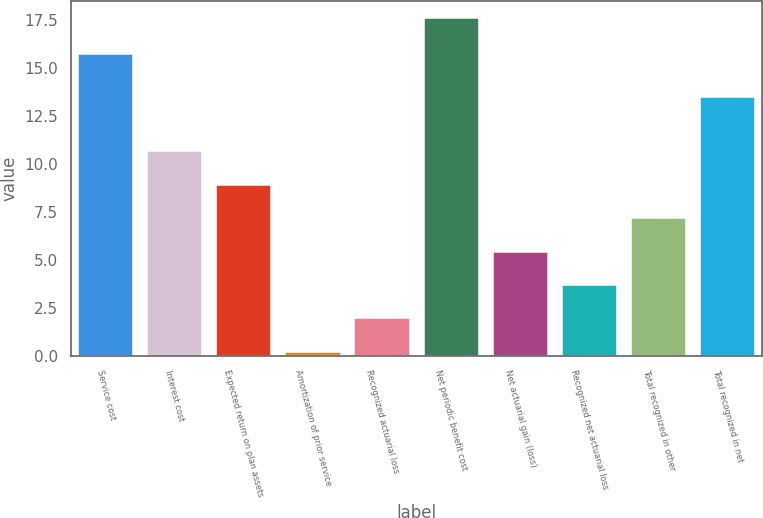<chart> <loc_0><loc_0><loc_500><loc_500><bar_chart><fcel>Service cost<fcel>Interest cost<fcel>Expected return on plan assets<fcel>Amortization of prior service<fcel>Recognized actuarial loss<fcel>Net periodic benefit cost<fcel>Net actuarial gain (loss)<fcel>Recognized net actuarial loss<fcel>Total recognized in other<fcel>Total recognized in net<nl><fcel>15.7<fcel>10.64<fcel>8.9<fcel>0.2<fcel>1.94<fcel>17.6<fcel>5.42<fcel>3.68<fcel>7.16<fcel>13.5<nl></chart> 